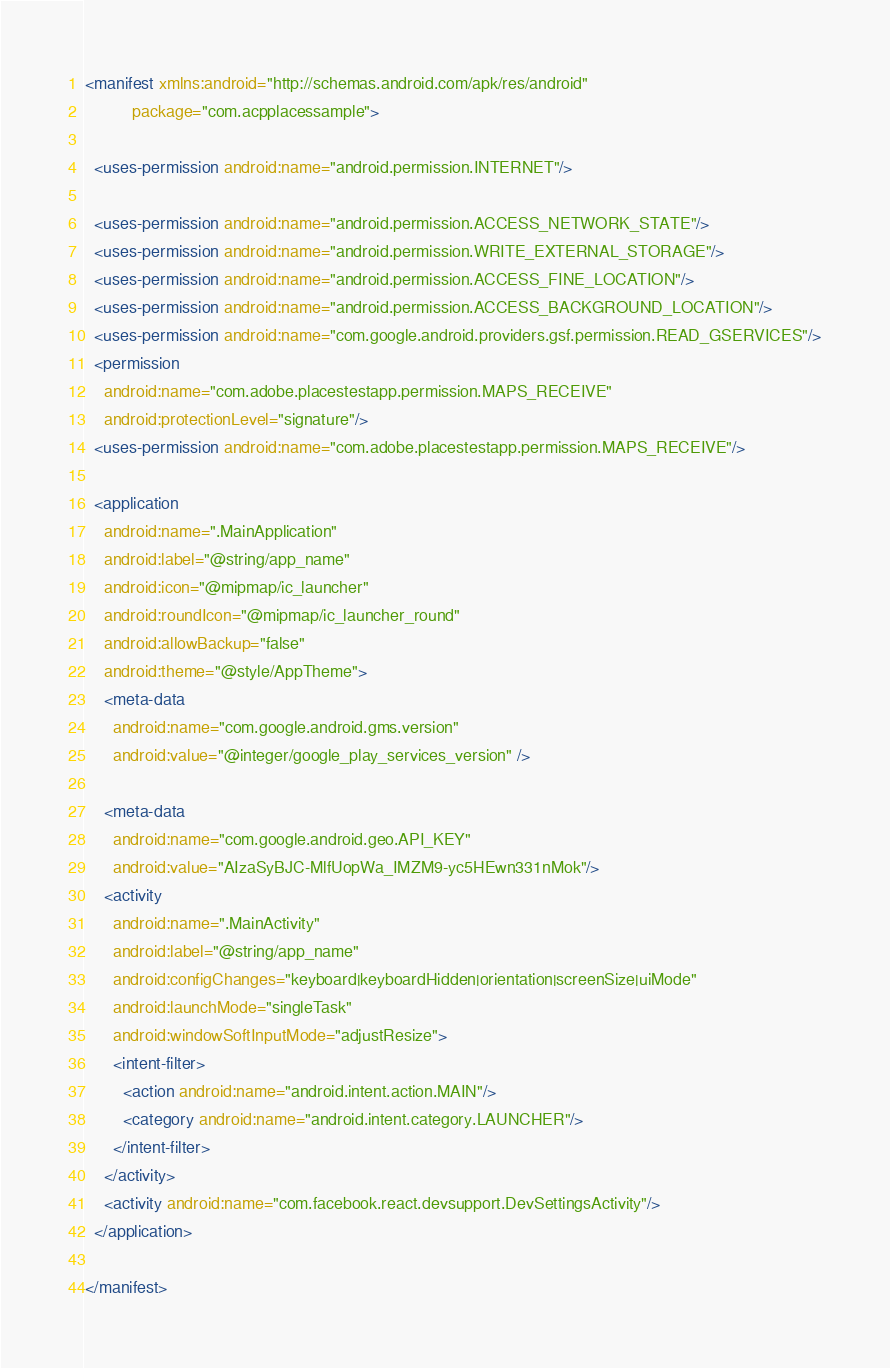<code> <loc_0><loc_0><loc_500><loc_500><_XML_><manifest xmlns:android="http://schemas.android.com/apk/res/android"
          package="com.acpplacessample">

  <uses-permission android:name="android.permission.INTERNET"/>

  <uses-permission android:name="android.permission.ACCESS_NETWORK_STATE"/>
  <uses-permission android:name="android.permission.WRITE_EXTERNAL_STORAGE"/>
  <uses-permission android:name="android.permission.ACCESS_FINE_LOCATION"/>
  <uses-permission android:name="android.permission.ACCESS_BACKGROUND_LOCATION"/>
  <uses-permission android:name="com.google.android.providers.gsf.permission.READ_GSERVICES"/>
  <permission
    android:name="com.adobe.placestestapp.permission.MAPS_RECEIVE"
    android:protectionLevel="signature"/>
  <uses-permission android:name="com.adobe.placestestapp.permission.MAPS_RECEIVE"/>

  <application
    android:name=".MainApplication"
    android:label="@string/app_name"
    android:icon="@mipmap/ic_launcher"
    android:roundIcon="@mipmap/ic_launcher_round"
    android:allowBackup="false"
    android:theme="@style/AppTheme">
    <meta-data
      android:name="com.google.android.gms.version"
      android:value="@integer/google_play_services_version" />

    <meta-data
      android:name="com.google.android.geo.API_KEY"
      android:value="AIzaSyBJC-MlfUopWa_IMZM9-yc5HEwn331nMok"/>
    <activity
      android:name=".MainActivity"
      android:label="@string/app_name"
      android:configChanges="keyboard|keyboardHidden|orientation|screenSize|uiMode"
      android:launchMode="singleTask"
      android:windowSoftInputMode="adjustResize">
      <intent-filter>
        <action android:name="android.intent.action.MAIN"/>
        <category android:name="android.intent.category.LAUNCHER"/>
      </intent-filter>
    </activity>
    <activity android:name="com.facebook.react.devsupport.DevSettingsActivity"/>
  </application>

</manifest>
</code> 